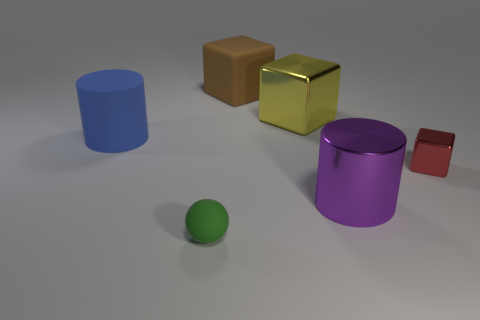Is the size of the rubber cylinder the same as the yellow shiny cube that is behind the tiny metallic thing?
Ensure brevity in your answer.  Yes. How many things are large blocks or big purple balls?
Provide a short and direct response. 2. What number of other things are there of the same size as the red block?
Offer a very short reply. 1. Does the large rubber cylinder have the same color as the metallic cube that is in front of the yellow metallic cube?
Your answer should be very brief. No. What number of cubes are either blue matte objects or metallic things?
Keep it short and to the point. 2. Are there any other things that are the same color as the big metal cylinder?
Your answer should be very brief. No. There is a big cube that is on the right side of the rubber thing that is right of the small green rubber thing; what is its material?
Keep it short and to the point. Metal. Does the red cube have the same material as the cylinder that is on the right side of the tiny green thing?
Your response must be concise. Yes. What number of things are large brown matte things behind the tiny cube or big blocks?
Your response must be concise. 2. Are there any small shiny blocks that have the same color as the small shiny thing?
Your answer should be compact. No. 